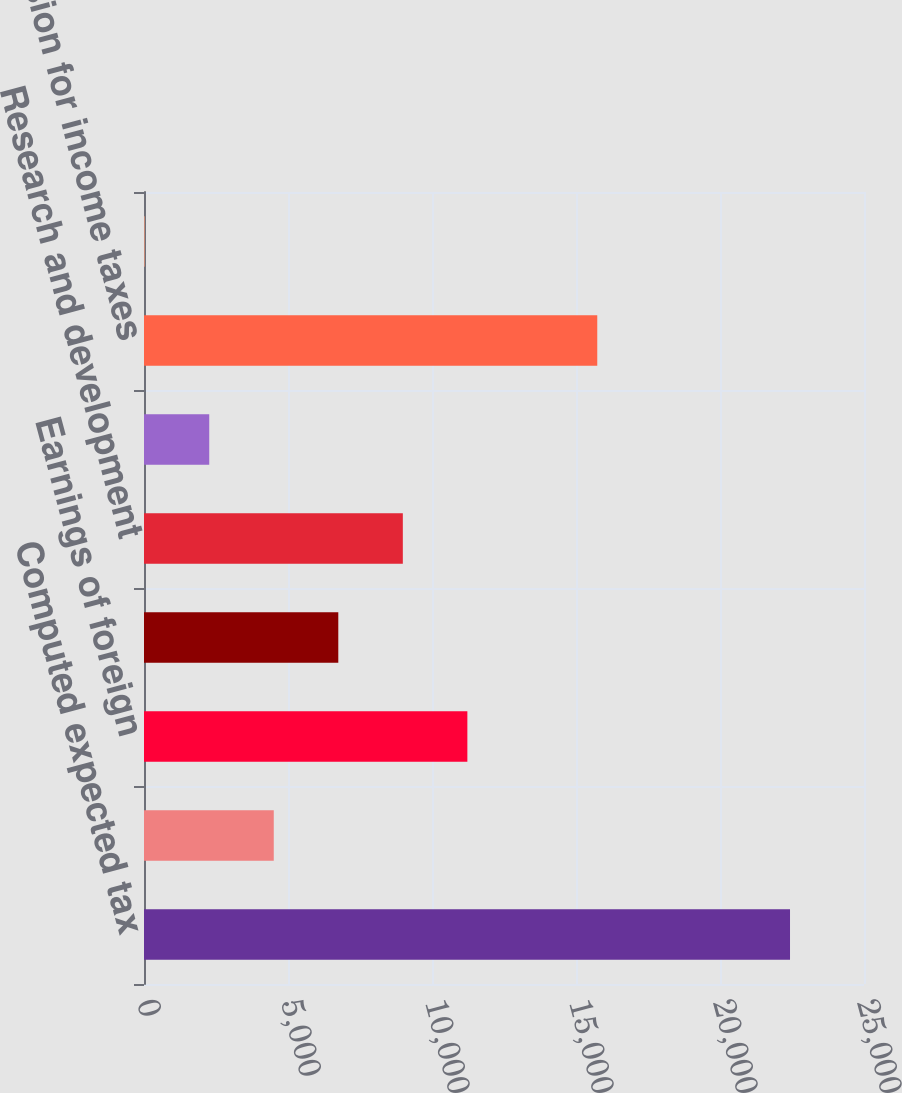<chart> <loc_0><loc_0><loc_500><loc_500><bar_chart><fcel>Computed expected tax<fcel>State taxes net of federal<fcel>Earnings of foreign<fcel>Domestic production activities<fcel>Research and development<fcel>Other<fcel>Provision for income taxes<fcel>Effective tax rate<nl><fcel>22431<fcel>4505.88<fcel>11227.8<fcel>6746.52<fcel>8987.16<fcel>2265.24<fcel>15738<fcel>24.6<nl></chart> 